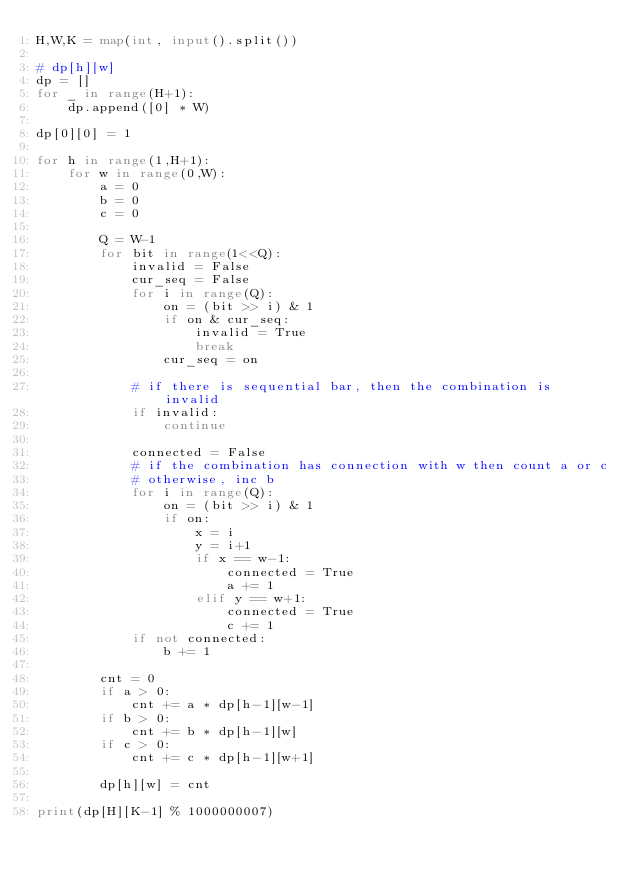Convert code to text. <code><loc_0><loc_0><loc_500><loc_500><_Python_>H,W,K = map(int, input().split())

# dp[h][w]
dp = []
for _ in range(H+1):
    dp.append([0] * W)

dp[0][0] = 1

for h in range(1,H+1):
    for w in range(0,W):
        a = 0
        b = 0
        c = 0
        
        Q = W-1
        for bit in range(1<<Q):
            invalid = False
            cur_seq = False
            for i in range(Q):
                on = (bit >> i) & 1
                if on & cur_seq:
                    invalid = True
                    break
                cur_seq = on

            # if there is sequential bar, then the combination is invalid
            if invalid:
                continue

            connected = False
            # if the combination has connection with w then count a or c
            # otherwise, inc b
            for i in range(Q):
                on = (bit >> i) & 1
                if on:
                    x = i
                    y = i+1
                    if x == w-1:
                        connected = True
                        a += 1
                    elif y == w+1:
                        connected = True
                        c += 1
            if not connected:
                b += 1

        cnt = 0
        if a > 0:
            cnt += a * dp[h-1][w-1]
        if b > 0:
            cnt += b * dp[h-1][w]
        if c > 0:
            cnt += c * dp[h-1][w+1]

        dp[h][w] = cnt

print(dp[H][K-1] % 1000000007)</code> 